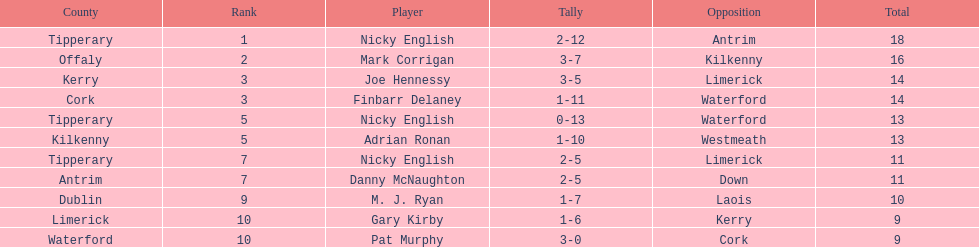How many people are on the list? 9. Parse the table in full. {'header': ['County', 'Rank', 'Player', 'Tally', 'Opposition', 'Total'], 'rows': [['Tipperary', '1', 'Nicky English', '2-12', 'Antrim', '18'], ['Offaly', '2', 'Mark Corrigan', '3-7', 'Kilkenny', '16'], ['Kerry', '3', 'Joe Hennessy', '3-5', 'Limerick', '14'], ['Cork', '3', 'Finbarr Delaney', '1-11', 'Waterford', '14'], ['Tipperary', '5', 'Nicky English', '0-13', 'Waterford', '13'], ['Kilkenny', '5', 'Adrian Ronan', '1-10', 'Westmeath', '13'], ['Tipperary', '7', 'Nicky English', '2-5', 'Limerick', '11'], ['Antrim', '7', 'Danny McNaughton', '2-5', 'Down', '11'], ['Dublin', '9', 'M. J. Ryan', '1-7', 'Laois', '10'], ['Limerick', '10', 'Gary Kirby', '1-6', 'Kerry', '9'], ['Waterford', '10', 'Pat Murphy', '3-0', 'Cork', '9']]} 